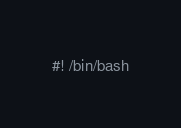Convert code to text. <code><loc_0><loc_0><loc_500><loc_500><_Bash_>#! /bin/bash
</code> 